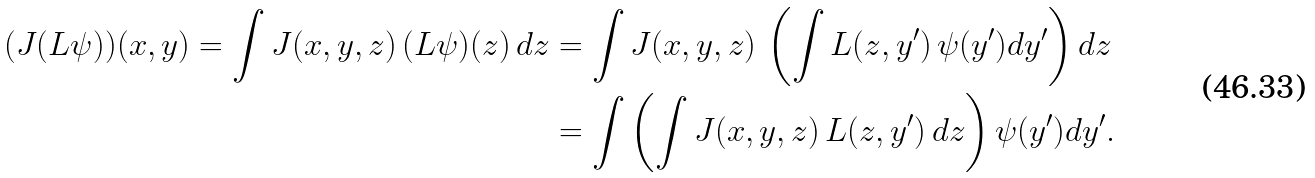Convert formula to latex. <formula><loc_0><loc_0><loc_500><loc_500>( J ( L \psi ) ) ( x , y ) = \int J ( x , y , z ) \, ( L \psi ) ( z ) \, d z & = \int J ( x , y , z ) \, \left ( \int L ( z , y ^ { \prime } ) \, \psi ( y ^ { \prime } ) d y ^ { \prime } \right ) d z \\ & = \int \left ( \int J ( x , y , z ) \, L ( z , y ^ { \prime } ) \, d z \right ) \psi ( y ^ { \prime } ) d y ^ { \prime } .</formula> 